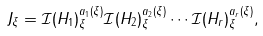Convert formula to latex. <formula><loc_0><loc_0><loc_500><loc_500>J _ { \xi } = \mathcal { I } ( H _ { 1 } ) ^ { a _ { 1 } ( \xi ) } _ { \xi } \mathcal { I } ( H _ { 2 } ) ^ { a _ { 2 } ( \xi ) } _ { \xi } \cdots \mathcal { I } ( H _ { r } ) ^ { a _ { r } ( \xi ) } _ { \xi } ,</formula> 